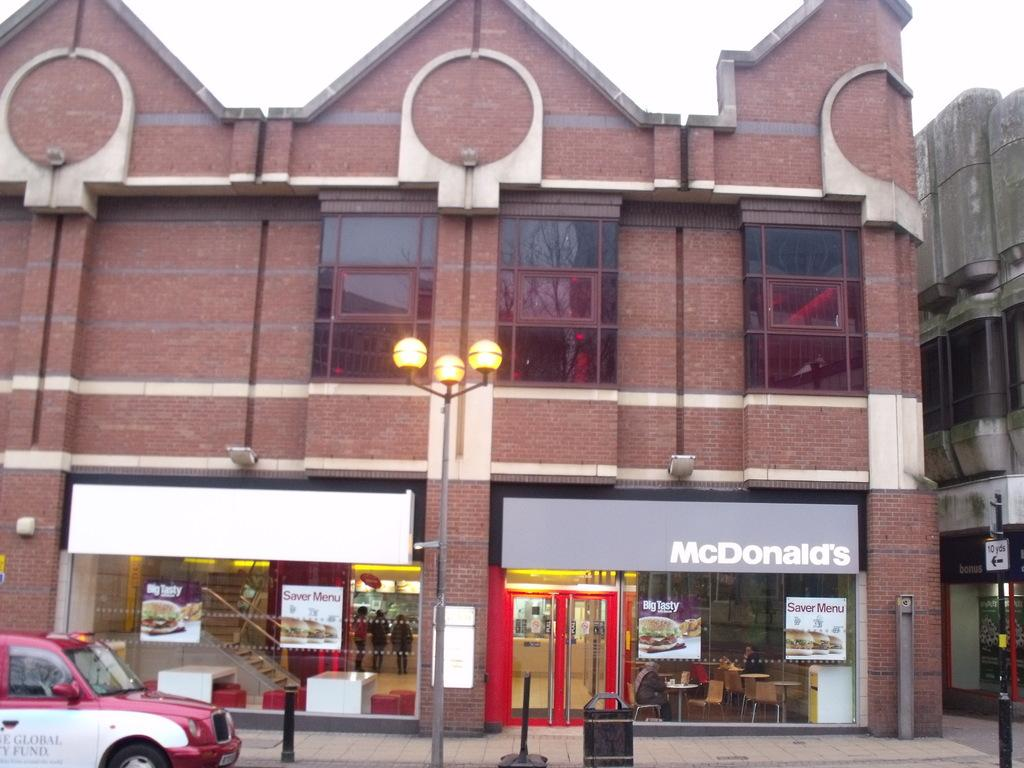<image>
Offer a succinct explanation of the picture presented. a McDonald's store that is in a building 